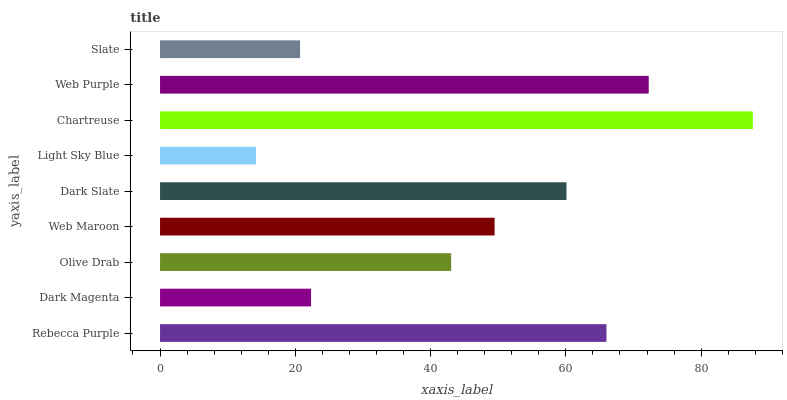Is Light Sky Blue the minimum?
Answer yes or no. Yes. Is Chartreuse the maximum?
Answer yes or no. Yes. Is Dark Magenta the minimum?
Answer yes or no. No. Is Dark Magenta the maximum?
Answer yes or no. No. Is Rebecca Purple greater than Dark Magenta?
Answer yes or no. Yes. Is Dark Magenta less than Rebecca Purple?
Answer yes or no. Yes. Is Dark Magenta greater than Rebecca Purple?
Answer yes or no. No. Is Rebecca Purple less than Dark Magenta?
Answer yes or no. No. Is Web Maroon the high median?
Answer yes or no. Yes. Is Web Maroon the low median?
Answer yes or no. Yes. Is Chartreuse the high median?
Answer yes or no. No. Is Slate the low median?
Answer yes or no. No. 